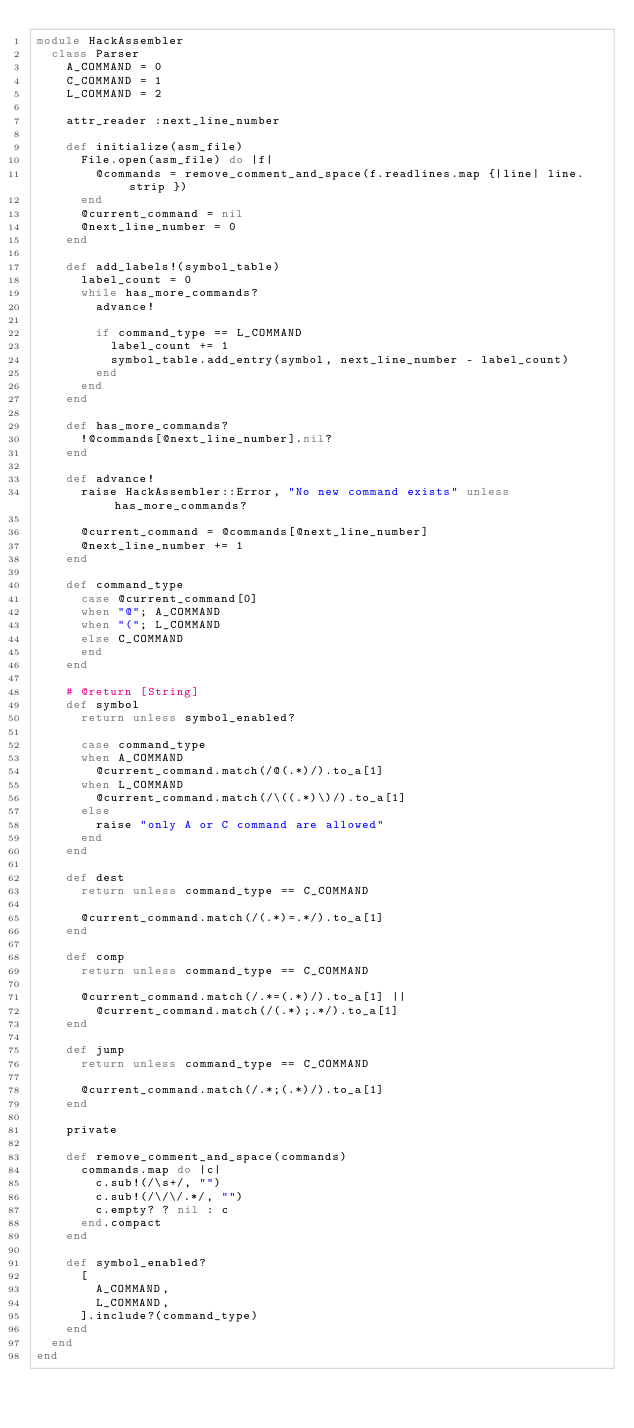<code> <loc_0><loc_0><loc_500><loc_500><_Ruby_>module HackAssembler
  class Parser
    A_COMMAND = 0
    C_COMMAND = 1
    L_COMMAND = 2

    attr_reader :next_line_number

    def initialize(asm_file)
      File.open(asm_file) do |f|
        @commands = remove_comment_and_space(f.readlines.map {|line| line.strip })
      end
      @current_command = nil
      @next_line_number = 0
    end

    def add_labels!(symbol_table)
      label_count = 0
      while has_more_commands?
        advance!

        if command_type == L_COMMAND
          label_count += 1
          symbol_table.add_entry(symbol, next_line_number - label_count)
        end
      end
    end

    def has_more_commands?
      !@commands[@next_line_number].nil?
    end

    def advance!
      raise HackAssembler::Error, "No new command exists" unless has_more_commands?

      @current_command = @commands[@next_line_number]
      @next_line_number += 1
    end

    def command_type
      case @current_command[0]
      when "@"; A_COMMAND
      when "("; L_COMMAND
      else C_COMMAND
      end
    end

    # @return [String]
    def symbol
      return unless symbol_enabled?

      case command_type
      when A_COMMAND
        @current_command.match(/@(.*)/).to_a[1]
      when L_COMMAND
        @current_command.match(/\((.*)\)/).to_a[1]
      else
        raise "only A or C command are allowed"
      end
    end

    def dest
      return unless command_type == C_COMMAND

      @current_command.match(/(.*)=.*/).to_a[1]
    end

    def comp
      return unless command_type == C_COMMAND

      @current_command.match(/.*=(.*)/).to_a[1] ||
        @current_command.match(/(.*);.*/).to_a[1]
    end

    def jump
      return unless command_type == C_COMMAND

      @current_command.match(/.*;(.*)/).to_a[1]
    end

    private

    def remove_comment_and_space(commands)
      commands.map do |c|
        c.sub!(/\s+/, "")
        c.sub!(/\/\/.*/, "")
        c.empty? ? nil : c
      end.compact
    end

    def symbol_enabled?
      [
        A_COMMAND,
        L_COMMAND,
      ].include?(command_type)
    end
  end
end
</code> 